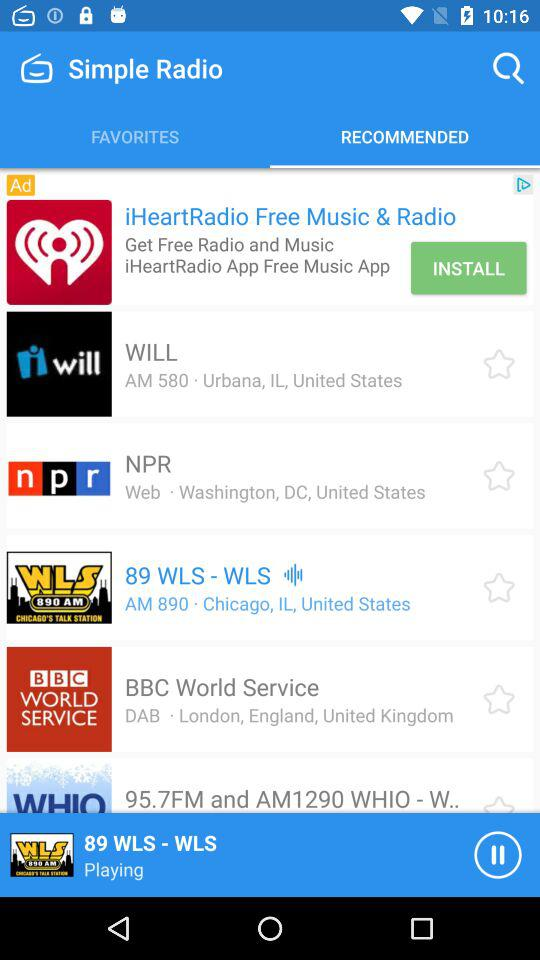Which radio station is playing? The playing radio station is "89 WLS - WLS". 